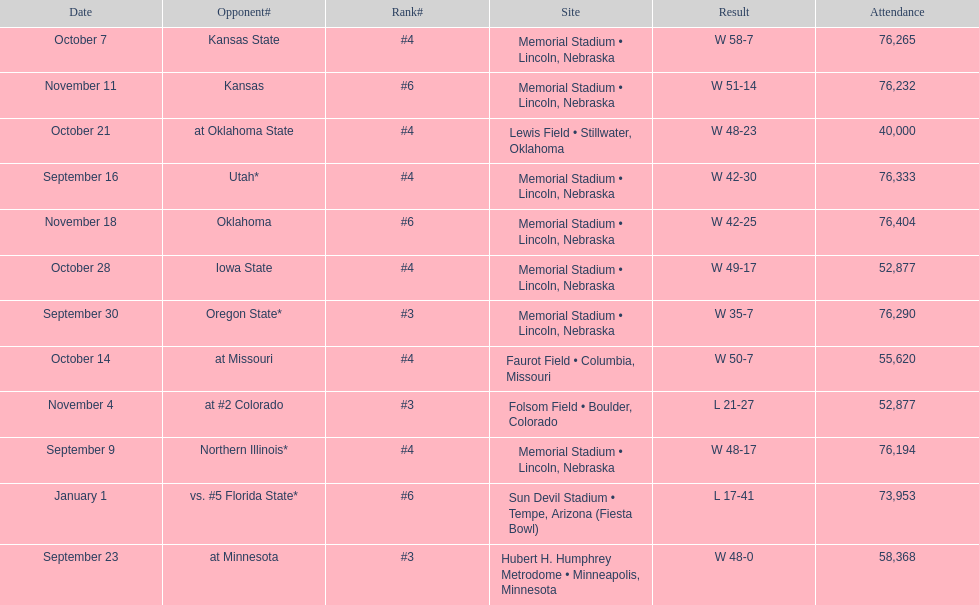Parse the table in full. {'header': ['Date', 'Opponent#', 'Rank#', 'Site', 'Result', 'Attendance'], 'rows': [['October 7', 'Kansas State', '#4', 'Memorial Stadium • Lincoln, Nebraska', 'W\xa058-7', '76,265'], ['November 11', 'Kansas', '#6', 'Memorial Stadium • Lincoln, Nebraska', 'W\xa051-14', '76,232'], ['October 21', 'at\xa0Oklahoma State', '#4', 'Lewis Field • Stillwater, Oklahoma', 'W\xa048-23', '40,000'], ['September 16', 'Utah*', '#4', 'Memorial Stadium • Lincoln, Nebraska', 'W\xa042-30', '76,333'], ['November 18', 'Oklahoma', '#6', 'Memorial Stadium • Lincoln, Nebraska', 'W\xa042-25', '76,404'], ['October 28', 'Iowa State', '#4', 'Memorial Stadium • Lincoln, Nebraska', 'W\xa049-17', '52,877'], ['September 30', 'Oregon State*', '#3', 'Memorial Stadium • Lincoln, Nebraska', 'W\xa035-7', '76,290'], ['October 14', 'at\xa0Missouri', '#4', 'Faurot Field • Columbia, Missouri', 'W\xa050-7', '55,620'], ['November 4', 'at\xa0#2\xa0Colorado', '#3', 'Folsom Field • Boulder, Colorado', 'L\xa021-27', '52,877'], ['September 9', 'Northern Illinois*', '#4', 'Memorial Stadium • Lincoln, Nebraska', 'W\xa048-17', '76,194'], ['January 1', 'vs.\xa0#5\xa0Florida State*', '#6', 'Sun Devil Stadium • Tempe, Arizona (Fiesta Bowl)', 'L\xa017-41', '73,953'], ['September 23', 'at\xa0Minnesota', '#3', 'Hubert H. Humphrey Metrodome • Minneapolis, Minnesota', 'W\xa048-0', '58,368']]} What site at most is taken place? Memorial Stadium • Lincoln, Nebraska. 